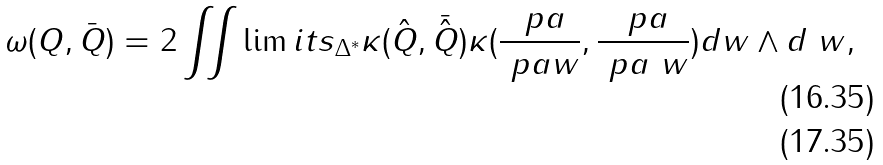Convert formula to latex. <formula><loc_0><loc_0><loc_500><loc_500>\omega ( Q , \bar { Q } ) & = 2 \iint \lim i t s _ { \Delta ^ { * } } \kappa ( \hat { Q } , \bar { \hat { Q } } ) \kappa ( \frac { \ p a } { \ p a w } , \frac { \ p a } { \ p a \ w } ) d w \wedge d \ w , \\</formula> 